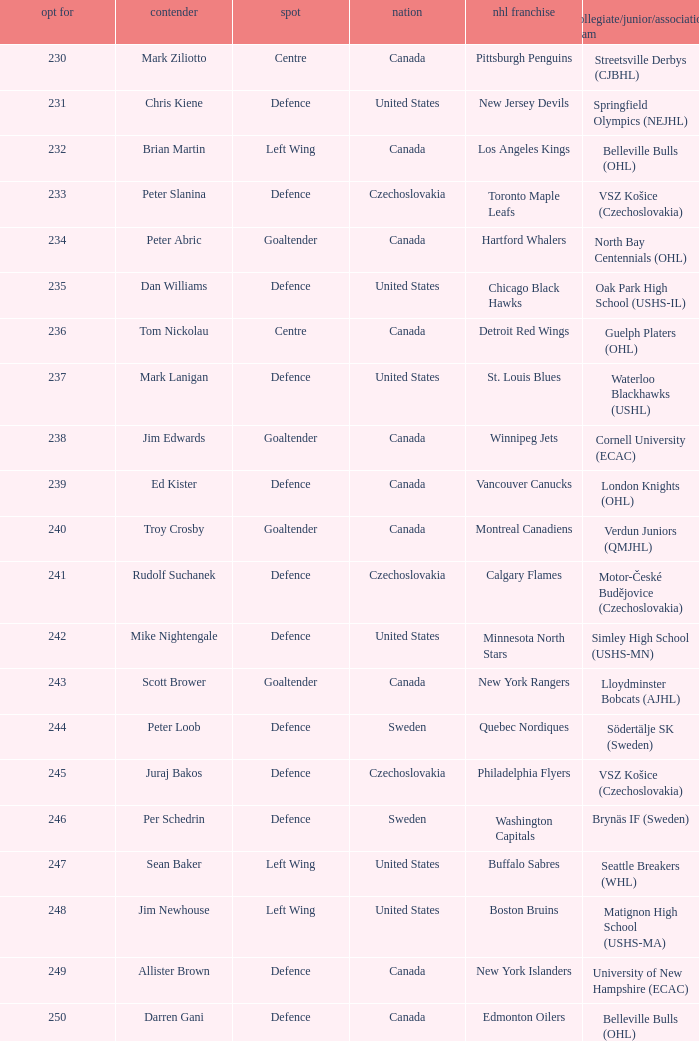List the players for team brynäs if (sweden). Per Schedrin. 